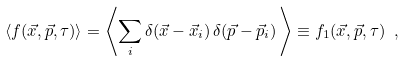Convert formula to latex. <formula><loc_0><loc_0><loc_500><loc_500>\langle f ( \vec { x } , \vec { p } , \tau ) \rangle = \left \langle \sum _ { i } \delta ( \vec { x } - \vec { x } _ { i } ) \, \delta ( \vec { p } - \vec { p } _ { i } ) \, \right \rangle \equiv f _ { 1 } ( \vec { x } , \vec { p } , \tau ) \ ,</formula> 